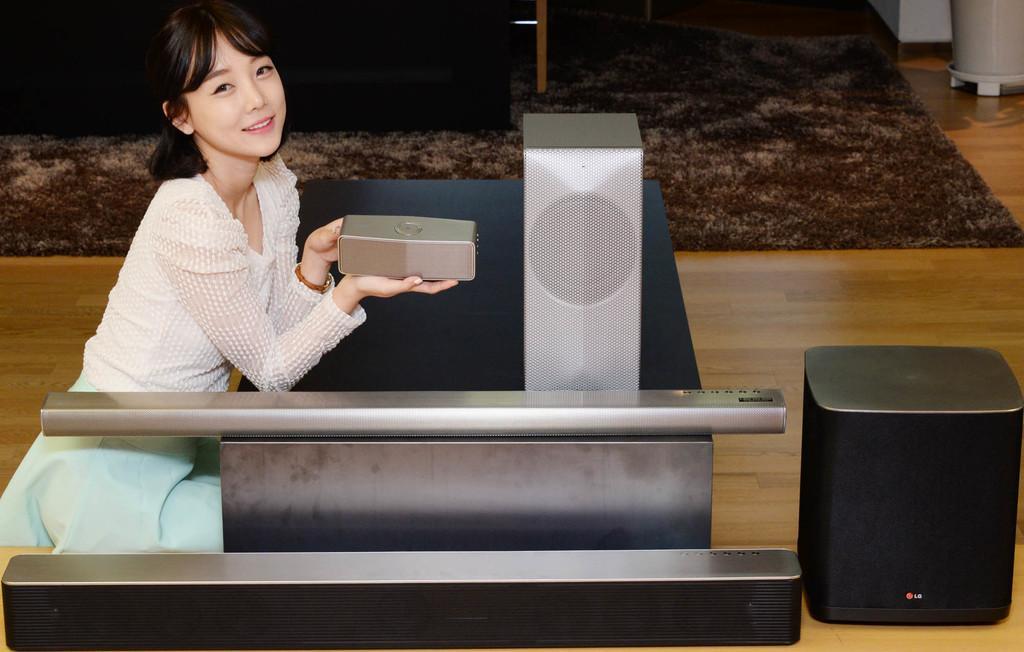In one or two sentences, can you explain what this image depicts? This image is taken inside a room. In the left side of the image a woman is sitting and holding something in her hand. In the right side of the image there is a speaker box on the floor. There is a floor and a floor mat on it. 